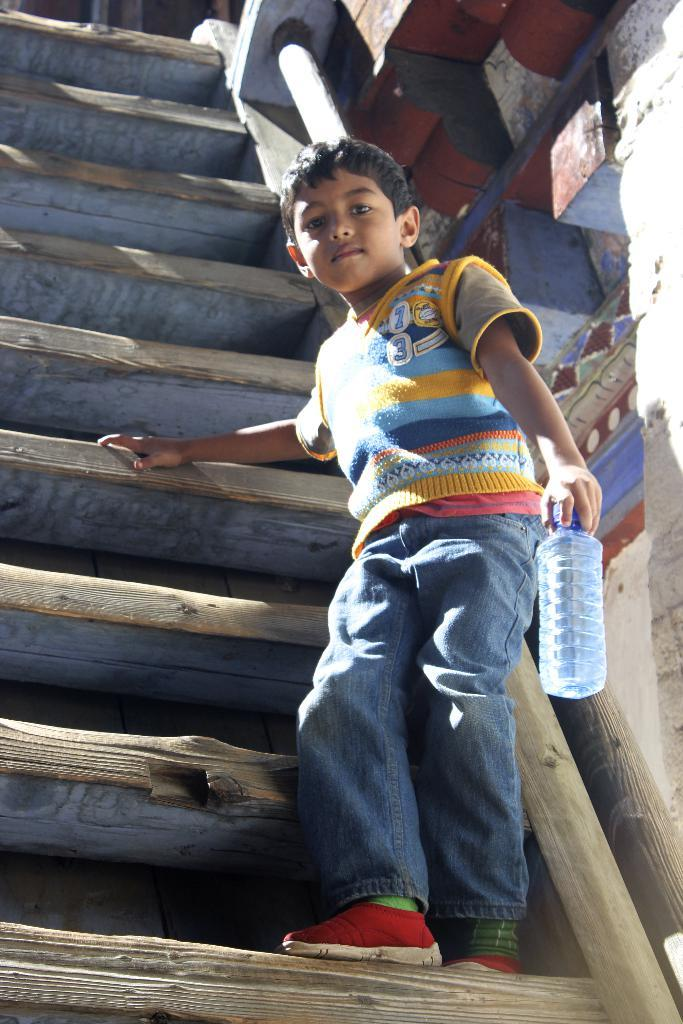What is the main subject of the image? The main subject of the image is a kid. Where is the kid located in the image? The kid is standing on the stairs. What is the kid holding in the image? The kid is holding a water bottle. What type of bird can be seen flying in the image? There is no bird present in the image. How many cars are visible in the image? There are no cars visible in the image. 